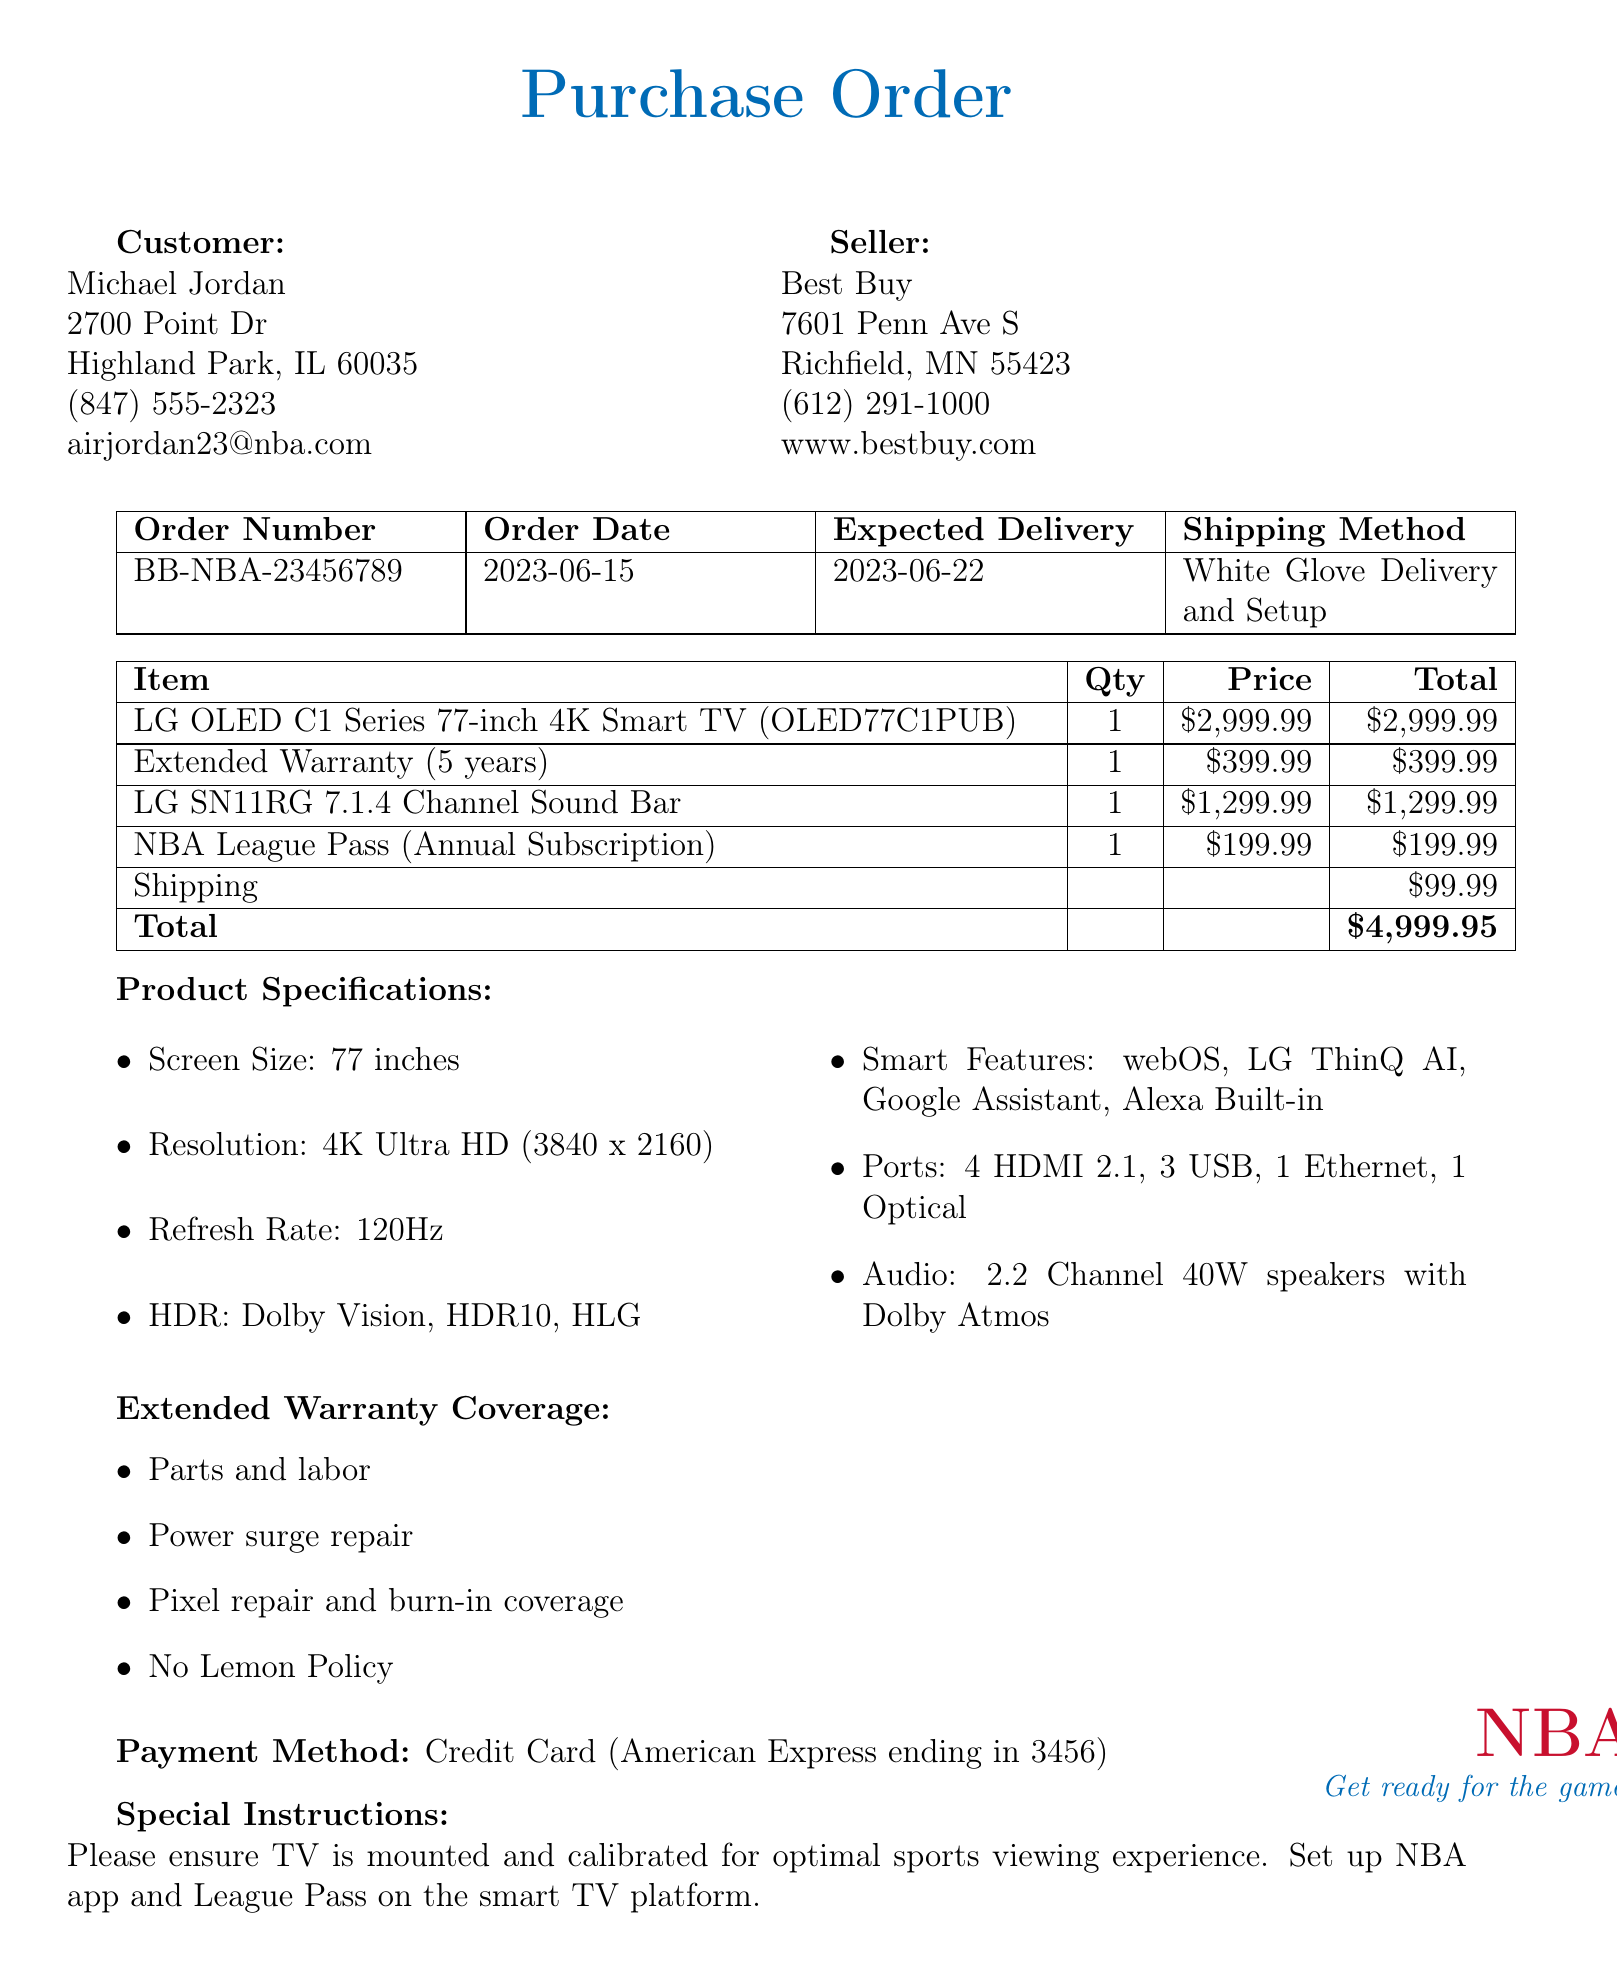What is the customer's name? The customer's name is listed in the document as Michael Jordan.
Answer: Michael Jordan What is the model number of the TV? The model number of the LG OLED C1 Series TV is specified in the document as OLED77C1PUB.
Answer: OLED77C1PUB What is the total price of the purchase? The total price includes the TV, warranty, soundbar, NBA subscription, and shipping costs, totaling $4,999.95.
Answer: $4,999.95 How long is the extended warranty coverage? The extended warranty coverage is indicated in the document to be 5 years.
Answer: 5 years What shipping method is used for delivery? The shipping method mentioned in the document is White Glove Delivery and Setup.
Answer: White Glove Delivery and Setup Which smart features are included with the TV? The document lists smart features such as webOS, LG ThinQ AI, Google Assistant, and Alexa Built-in.
Answer: webOS, LG ThinQ AI, Google Assistant, Alexa Built-in What is the price of the additional sound bar? The price for the LG SN11RG 7.1.4 Channel Sound Bar is mentioned as $1,299.99.
Answer: $1,299.99 What special instruction is noted for the delivery? The document emphasizes the instruction to ensure the TV is mounted and calibrated for optimal sports viewing experience.
Answer: Ensure TV is mounted and calibrated for optimal sports viewing experience 